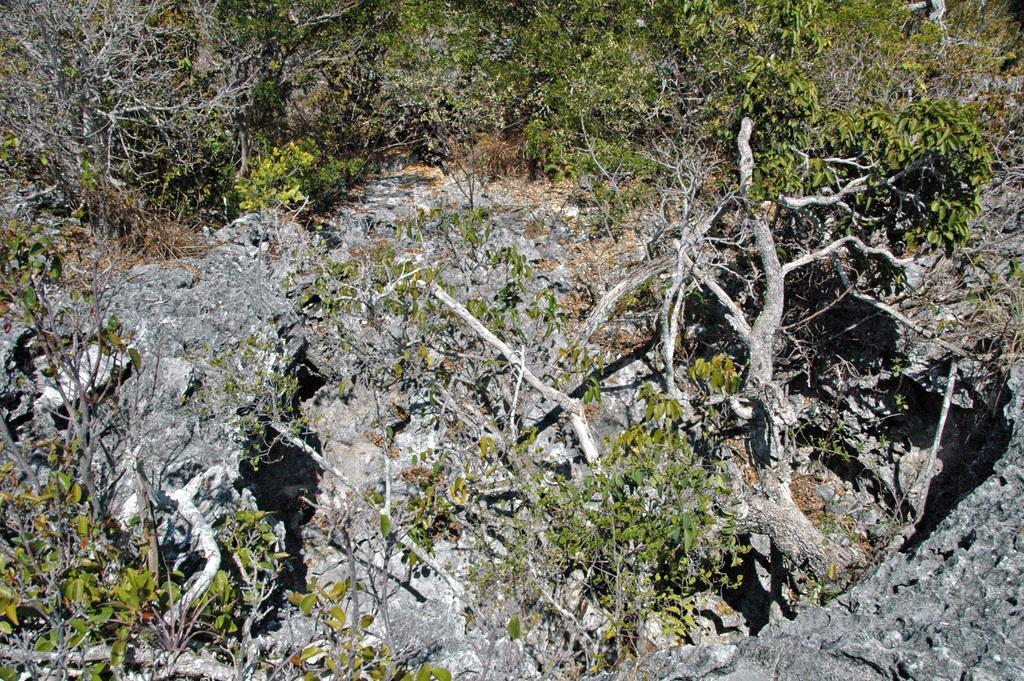In one or two sentences, can you explain what this image depicts? In this image in the front there are plants and in the background there are trees. 